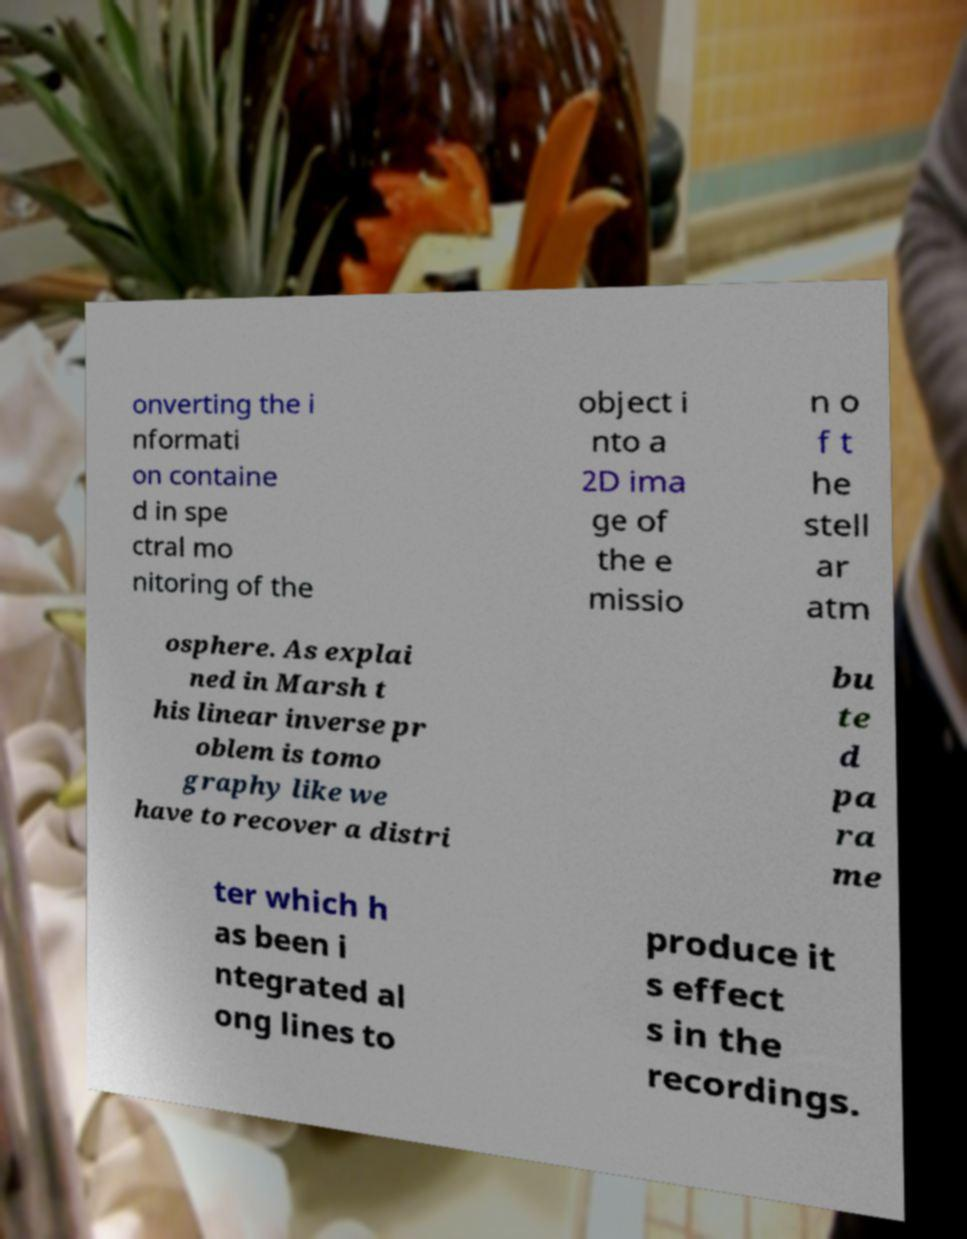Could you extract and type out the text from this image? onverting the i nformati on containe d in spe ctral mo nitoring of the object i nto a 2D ima ge of the e missio n o f t he stell ar atm osphere. As explai ned in Marsh t his linear inverse pr oblem is tomo graphy like we have to recover a distri bu te d pa ra me ter which h as been i ntegrated al ong lines to produce it s effect s in the recordings. 